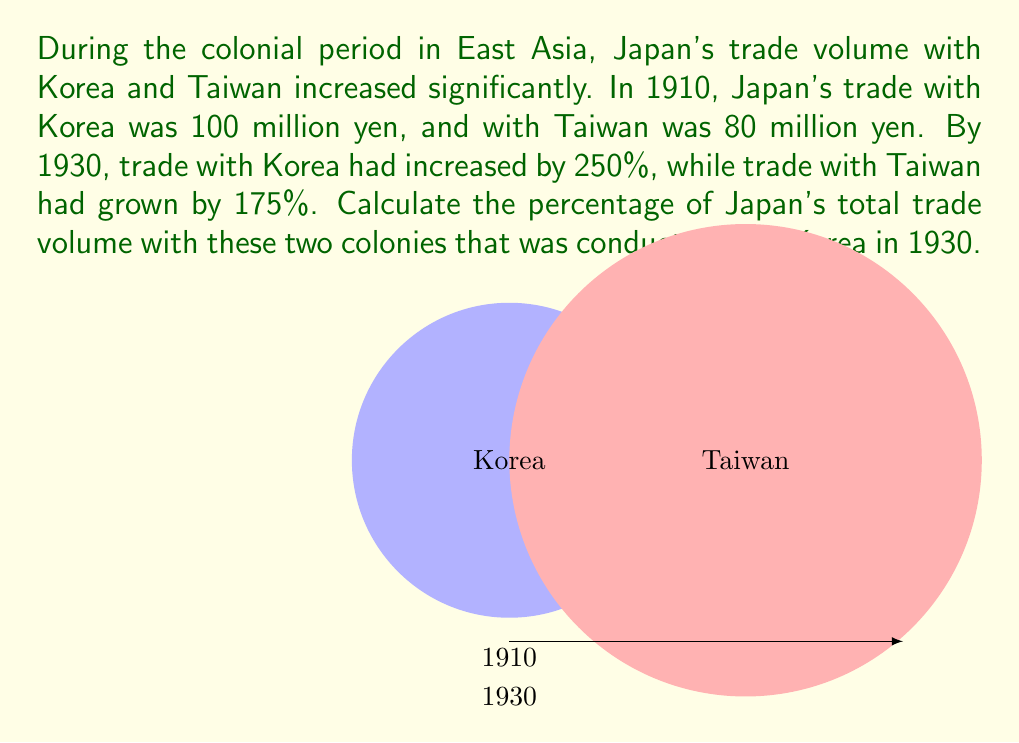Teach me how to tackle this problem. Let's approach this step-by-step:

1) First, let's calculate the trade volumes for 1930:

   Korea: $100 \text{ million yen} \times (1 + 2.50) = 350 \text{ million yen}$
   Taiwan: $80 \text{ million yen} \times (1 + 1.75) = 220 \text{ million yen}$

2) Now, let's calculate the total trade volume for 1930:

   $\text{Total} = 350 + 220 = 570 \text{ million yen}$

3) To find the percentage of trade with Korea, we use the formula:

   $$\text{Percentage} = \frac{\text{Trade with Korea}}{\text{Total Trade}} \times 100\%$$

4) Plugging in our values:

   $$\text{Percentage} = \frac{350}{570} \times 100\% \approx 61.40\%$$

Therefore, in 1930, approximately 61.40% of Japan's total trade volume with these two colonies was conducted with Korea.
Answer: $61.40\%$ 